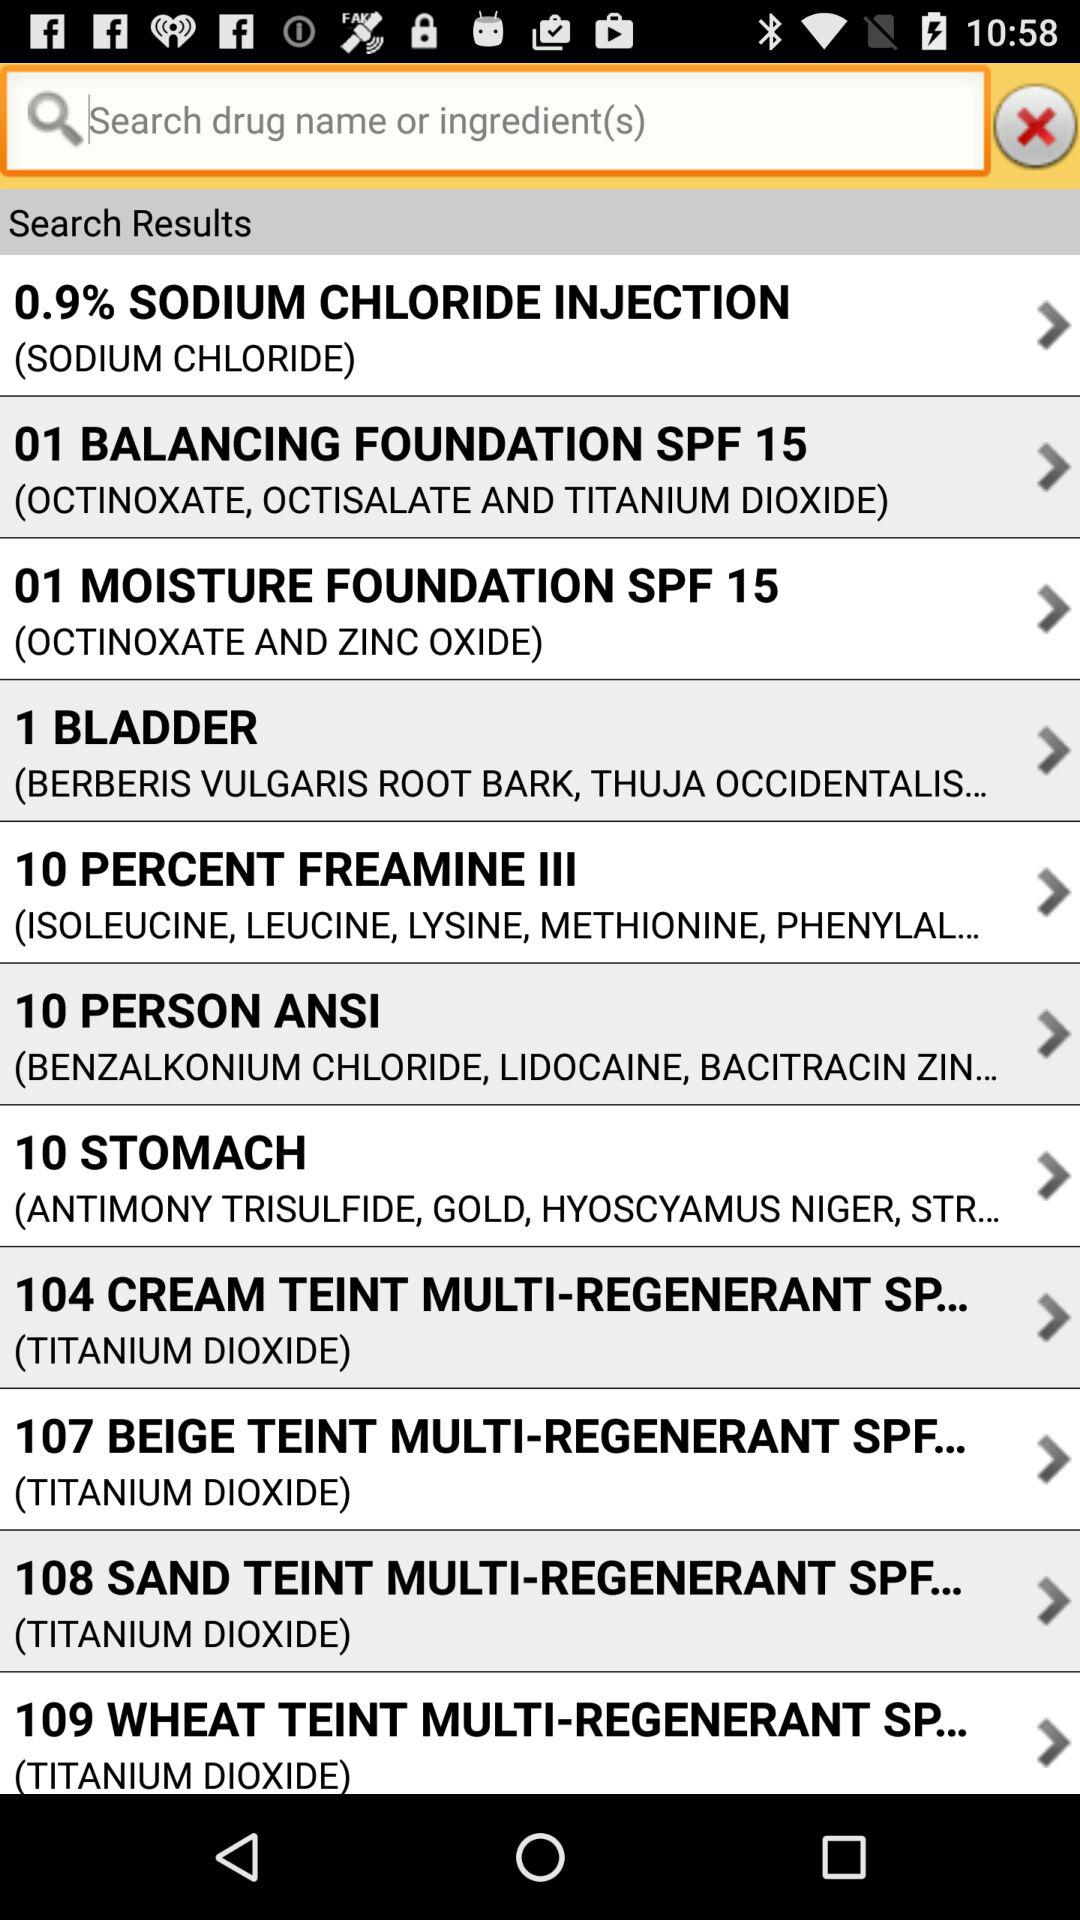What are the ingredients in "10 STOMACH"? The ingredients are antimony trisulfide, gold, Hyoscyamus niger and "STR...". 